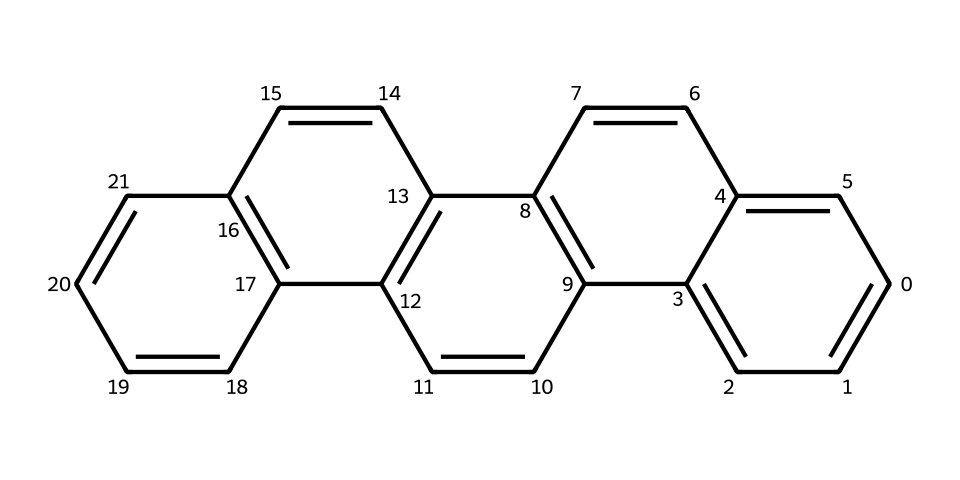What is the name of this polycyclic aromatic hydrocarbon? The SMILES representation corresponds to a chemical commonly known as coronene, which is a polycyclic aromatic hydrocarbon made up of several fused benzene rings.
Answer: coronene How many carbon atoms are present in the molecular structure? By analyzing the SMILES representation, we can count 24 carbon atoms indicated by the letters "c" in the structure. Each "c" represents a carbon atom in the fused aromatic system.
Answer: 24 What is the total number of rings in this compound? The structure displays a total of five aromatic rings, which can be identified by visualizing the fused benzene-like structures in the SMILES.
Answer: 5 Is this chemical symmetrical? Yes, the structure exhibits symmetry; the arrangement of the rings suggests a uniform distribution of carbon atoms around a center, characteristic of coronene.
Answer: yes What kind of intermolecular interactions would you expect this compound to exhibit? Given its polycyclic aromatic structure, coronene would primarily experience π-π stacking interactions, which are common in aromatic compounds. This occurs due to the alignment of the π-electron clouds above and below the aromatic structures.
Answer: π-π stacking What is the potential application of this compound in organic electronics? Due to its high charge mobility and stability, coronene is often used as an organic semiconductor material in the fabrication of organic electronic devices like transistors and solar cells.
Answer: organic semiconductor 